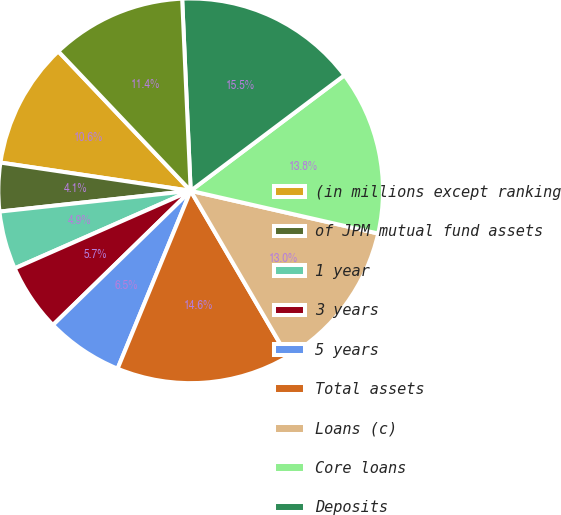Convert chart to OTSL. <chart><loc_0><loc_0><loc_500><loc_500><pie_chart><fcel>(in millions except ranking<fcel>of JPM mutual fund assets<fcel>1 year<fcel>3 years<fcel>5 years<fcel>Total assets<fcel>Loans (c)<fcel>Core loans<fcel>Deposits<fcel>Equity<nl><fcel>10.57%<fcel>4.07%<fcel>4.88%<fcel>5.69%<fcel>6.5%<fcel>14.63%<fcel>13.01%<fcel>13.82%<fcel>15.45%<fcel>11.38%<nl></chart> 